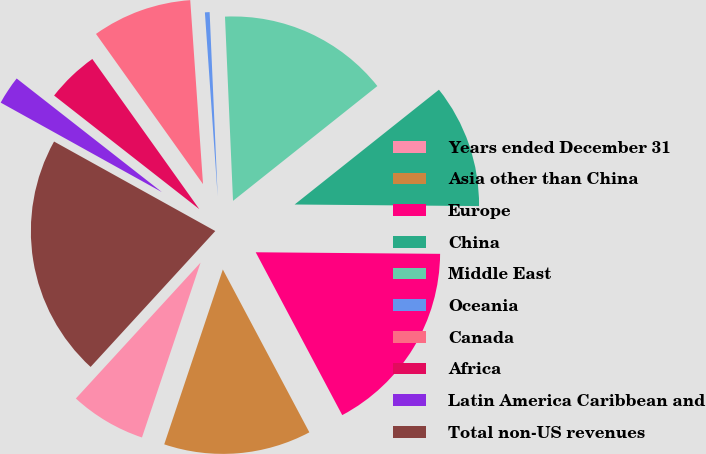Convert chart. <chart><loc_0><loc_0><loc_500><loc_500><pie_chart><fcel>Years ended December 31<fcel>Asia other than China<fcel>Europe<fcel>China<fcel>Middle East<fcel>Oceania<fcel>Canada<fcel>Africa<fcel>Latin America Caribbean and<fcel>Total non-US revenues<nl><fcel>6.67%<fcel>12.92%<fcel>17.09%<fcel>10.83%<fcel>15.0%<fcel>0.41%<fcel>8.75%<fcel>4.58%<fcel>2.5%<fcel>21.25%<nl></chart> 